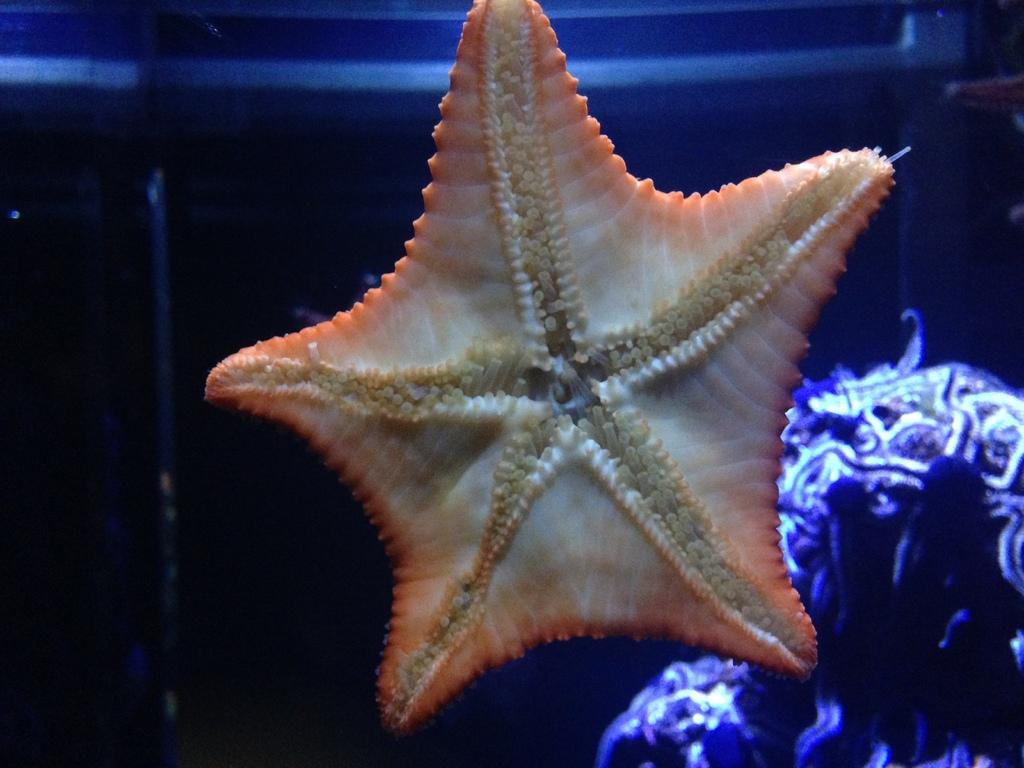What is the main subject in the middle of the image? There is a starfish in the middle of the image. What else can be seen in the image? There is an aquatic animal in the water at the right bottom of the image. What type of lock can be seen on the prison wall in the image? There is no lock or prison wall present in the image; it features a starfish and an aquatic animal in water. 